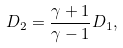<formula> <loc_0><loc_0><loc_500><loc_500>D _ { 2 } = \frac { \gamma + 1 } { \gamma - 1 } D _ { 1 } ,</formula> 